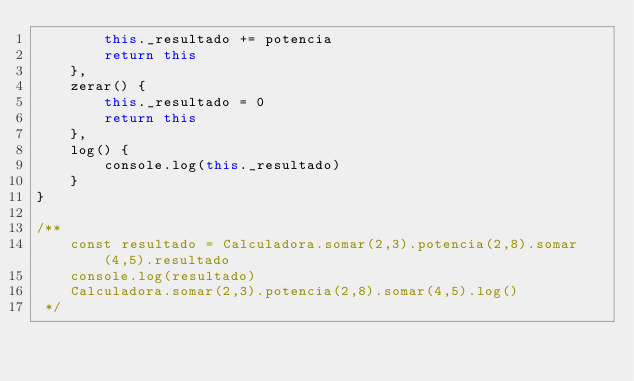<code> <loc_0><loc_0><loc_500><loc_500><_JavaScript_>        this._resultado += potencia
        return this
    },
    zerar() {
        this._resultado = 0
        return this
    },
    log() {
        console.log(this._resultado)
    }
}

/**
    const resultado = Calculadora.somar(2,3).potencia(2,8).somar(4,5).resultado
    console.log(resultado)
    Calculadora.somar(2,3).potencia(2,8).somar(4,5).log()
 */</code> 